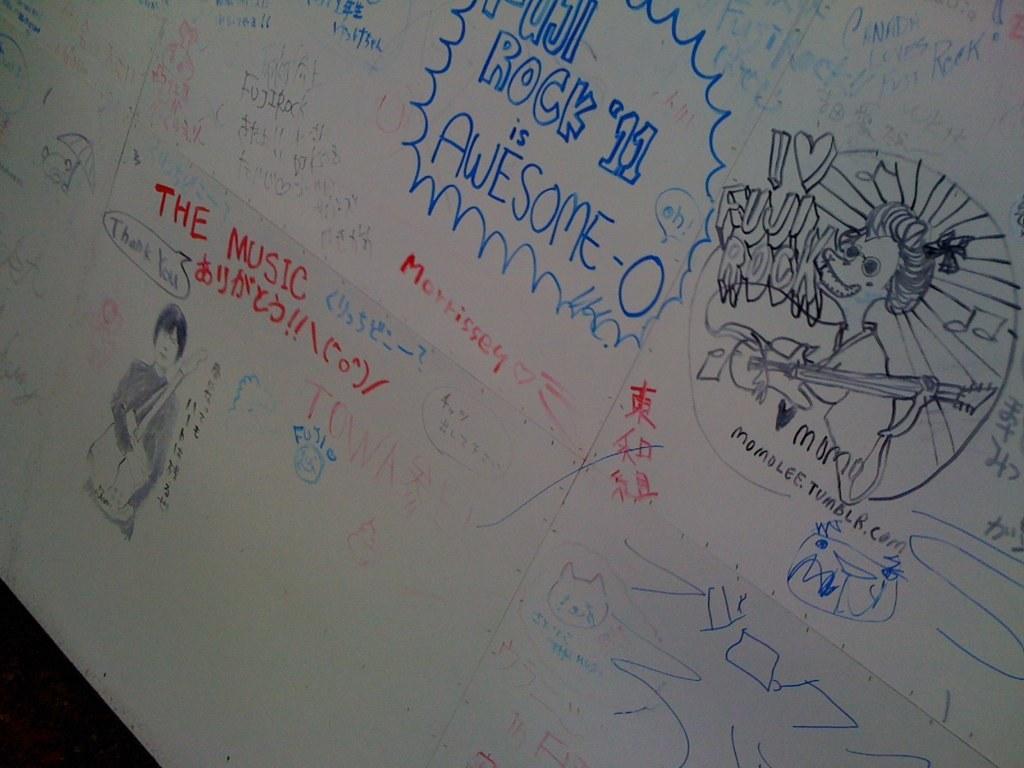What is awesome?
Make the answer very short. Rock '11. 